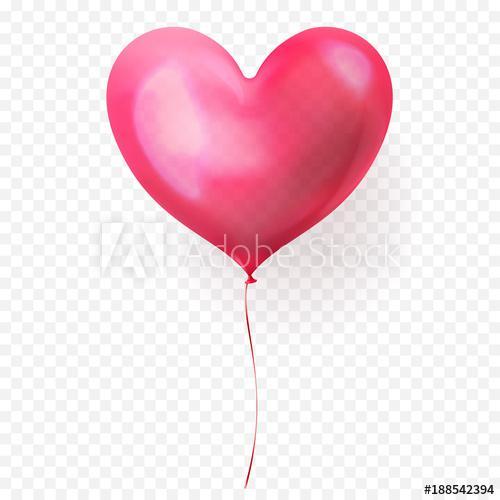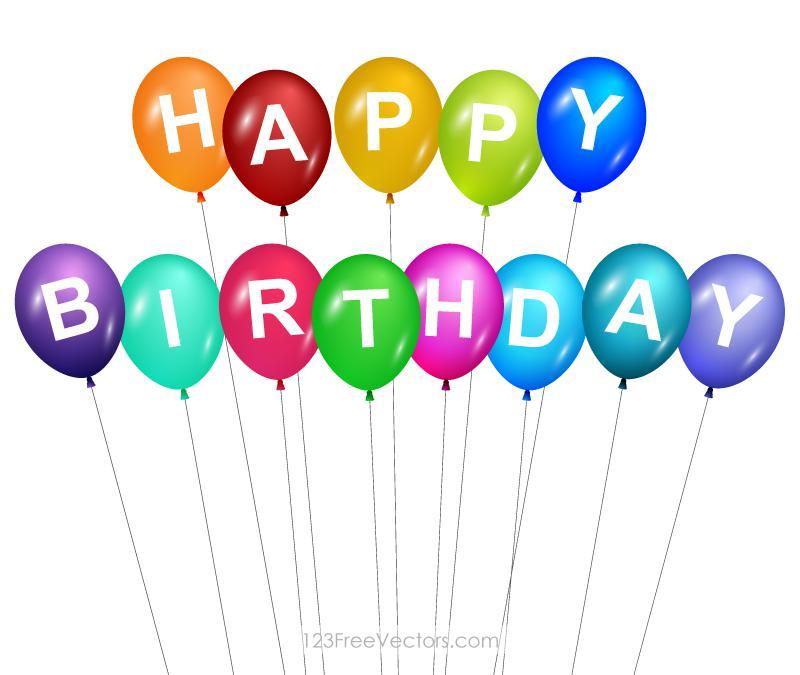The first image is the image on the left, the second image is the image on the right. Given the left and right images, does the statement "One image shows round balloons with dangling, non-straight strings under them, and contains no more than four balloons." hold true? Answer yes or no. No. The first image is the image on the left, the second image is the image on the right. Considering the images on both sides, is "The balloons are arranged vertically in one image, horizontally in the other." valid? Answer yes or no. No. 